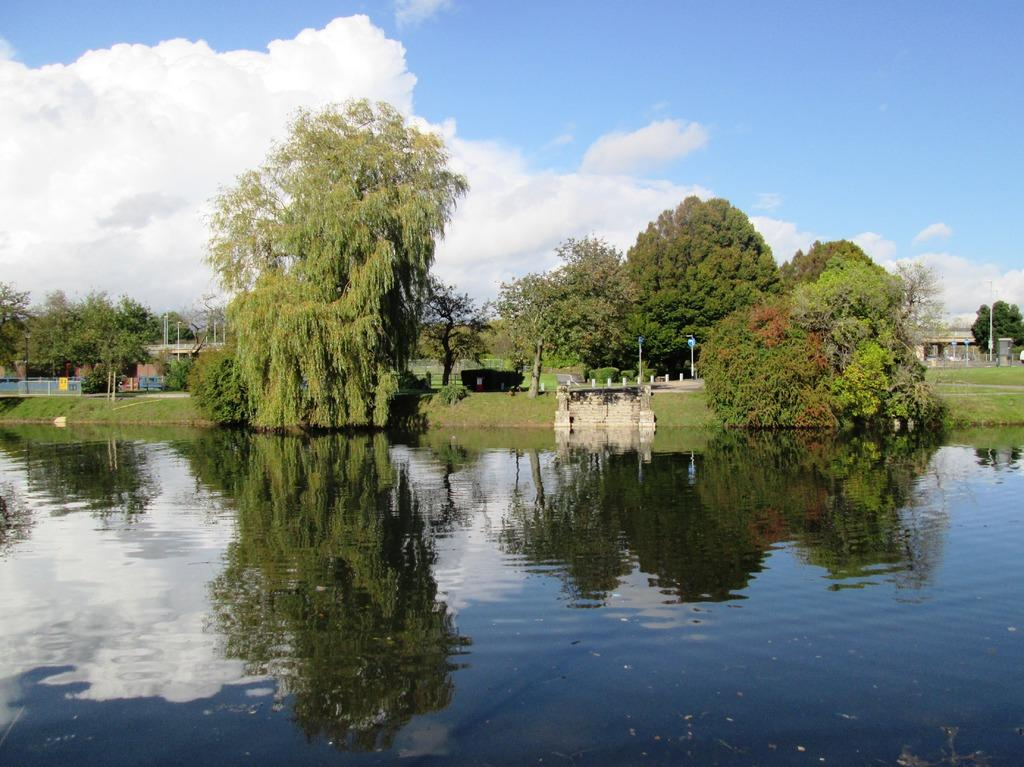What is the primary element visible in the image? There is water in the image. What other natural elements can be seen in the image? There are plants, trees, and the sky visible in the image. What man-made structures are present in the image? There are poles, boards, and buildings in the image. Can you describe the sky in the image? The sky is visible in the background of the image, and there are clouds present. What type of chin can be seen on the water in the image? There is no chin present in the image, as it features water, plants, trees, poles, boards, buildings, and the sky. 